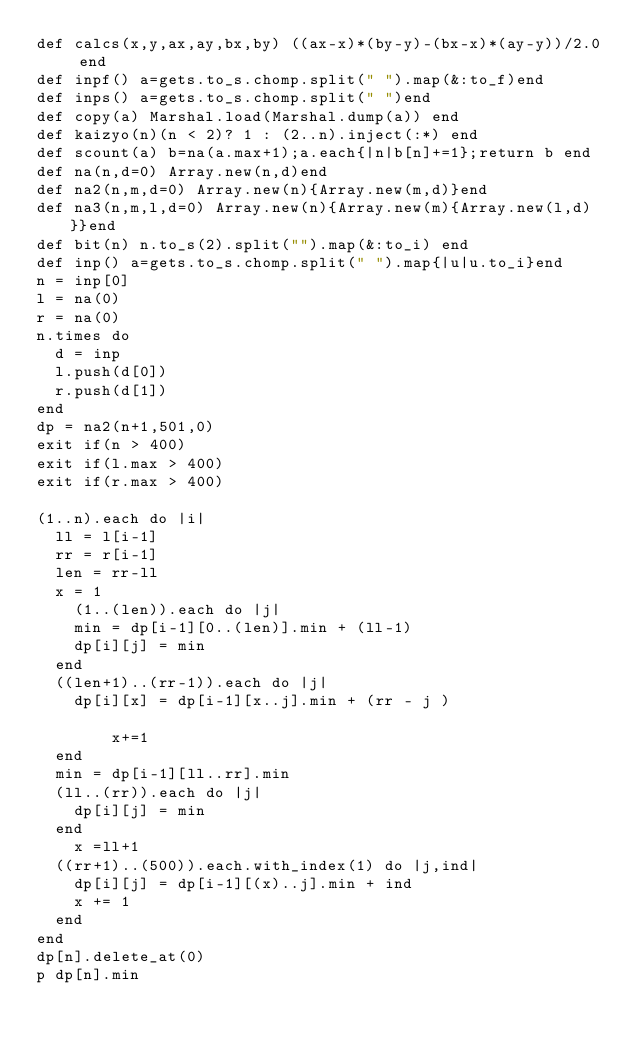Convert code to text. <code><loc_0><loc_0><loc_500><loc_500><_Crystal_>def calcs(x,y,ax,ay,bx,by) ((ax-x)*(by-y)-(bx-x)*(ay-y))/2.0 end
def inpf() a=gets.to_s.chomp.split(" ").map(&:to_f)end
def inps() a=gets.to_s.chomp.split(" ")end  
def copy(a) Marshal.load(Marshal.dump(a)) end
def kaizyo(n)(n < 2)? 1 : (2..n).inject(:*) end
def scount(a) b=na(a.max+1);a.each{|n|b[n]+=1};return b end
def na(n,d=0) Array.new(n,d)end
def na2(n,m,d=0) Array.new(n){Array.new(m,d)}end
def na3(n,m,l,d=0) Array.new(n){Array.new(m){Array.new(l,d)}}end
def bit(n) n.to_s(2).split("").map(&:to_i) end
def inp() a=gets.to_s.chomp.split(" ").map{|u|u.to_i}end
n = inp[0]
l = na(0)
r = na(0)
n.times do
  d = inp
  l.push(d[0])
  r.push(d[1])
end
dp = na2(n+1,501,0)
exit if(n > 400)
exit if(l.max > 400)
exit if(r.max > 400)

(1..n).each do |i|
  ll = l[i-1]
  rr = r[i-1]
  len = rr-ll
  x = 1
    (1..(len)).each do |j|
    min = dp[i-1][0..(len)].min + (ll-1)
    dp[i][j] = min
  end
  ((len+1)..(rr-1)).each do |j|
    dp[i][x] = dp[i-1][x..j].min + (rr - j )

        x+=1
  end
  min = dp[i-1][ll..rr].min
  (ll..(rr)).each do |j|
    dp[i][j] = min
  end
    x =ll+1
  ((rr+1)..(500)).each.with_index(1) do |j,ind|
    dp[i][j] = dp[i-1][(x)..j].min + ind
    x += 1
  end
end
dp[n].delete_at(0)
p dp[n].min</code> 